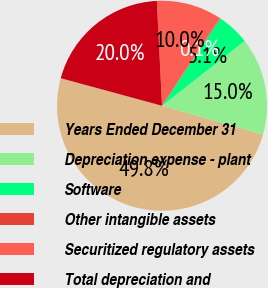<chart> <loc_0><loc_0><loc_500><loc_500><pie_chart><fcel>Years Ended December 31<fcel>Depreciation expense - plant<fcel>Software<fcel>Other intangible assets<fcel>Securitized regulatory assets<fcel>Total depreciation and<nl><fcel>49.8%<fcel>15.01%<fcel>5.07%<fcel>0.1%<fcel>10.04%<fcel>19.98%<nl></chart> 